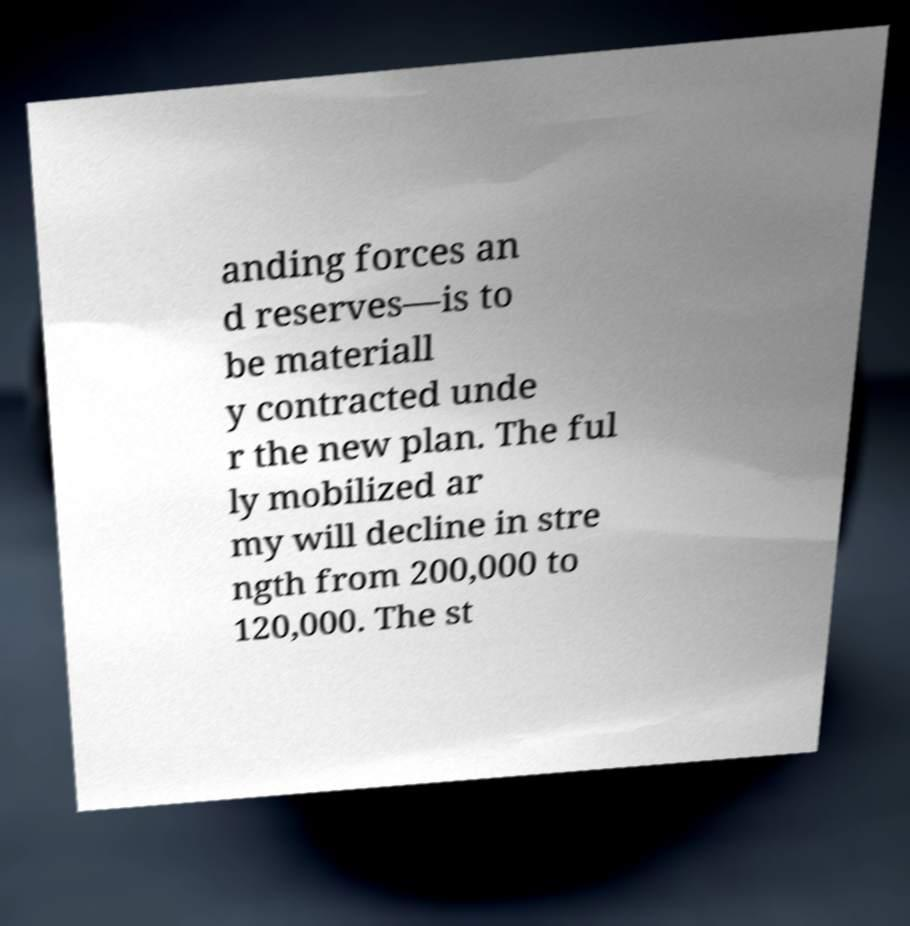Can you accurately transcribe the text from the provided image for me? anding forces an d reserves—is to be materiall y contracted unde r the new plan. The ful ly mobilized ar my will decline in stre ngth from 200,000 to 120,000. The st 